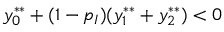Convert formula to latex. <formula><loc_0><loc_0><loc_500><loc_500>y _ { 0 } ^ { * * } + ( 1 - p _ { I } ) ( y _ { 1 } ^ { * * } + y _ { 2 } ^ { * * } ) < 0</formula> 